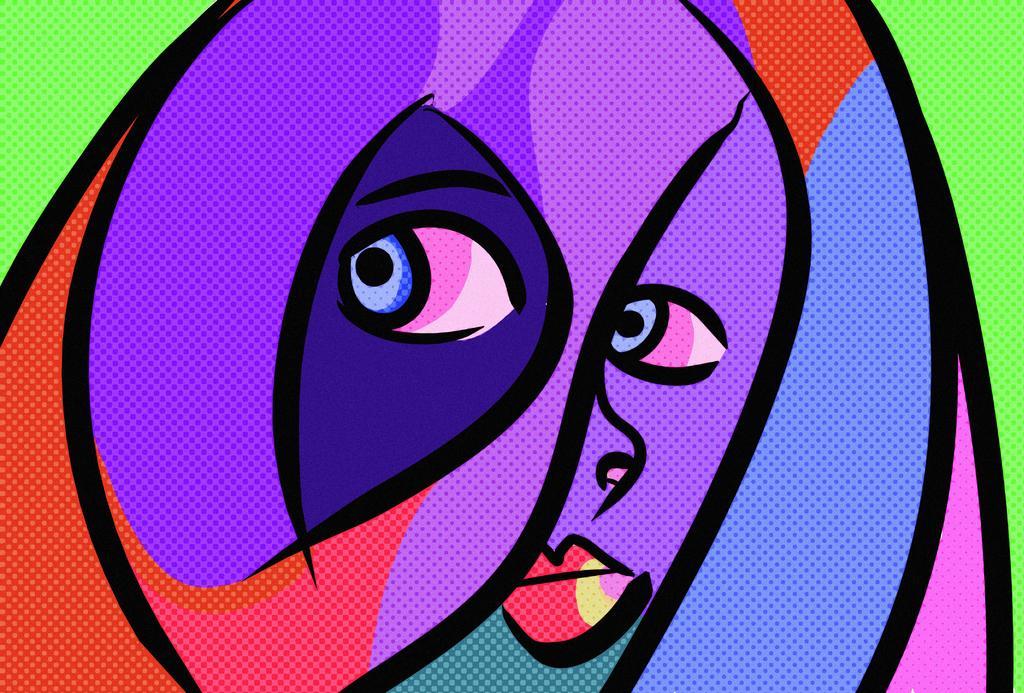In one or two sentences, can you explain what this image depicts? This is an digital art picture. In this image there is a picture of a woman with different colors. 